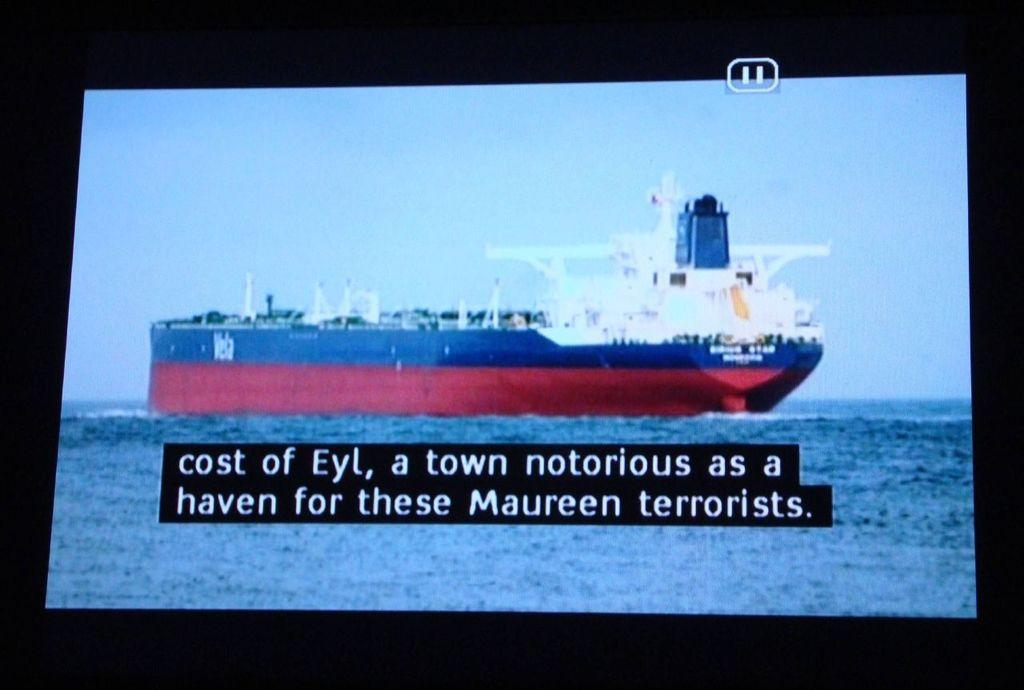<image>
Write a terse but informative summary of the picture. Shot of a large boat with closed captioning on a screen 